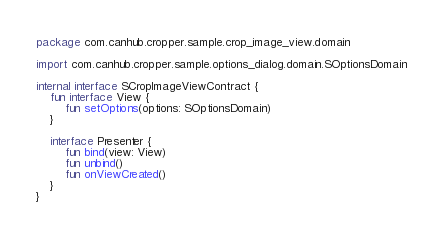Convert code to text. <code><loc_0><loc_0><loc_500><loc_500><_Kotlin_>package com.canhub.cropper.sample.crop_image_view.domain

import com.canhub.cropper.sample.options_dialog.domain.SOptionsDomain

internal interface SCropImageViewContract {
    fun interface View {
        fun setOptions(options: SOptionsDomain)
    }

    interface Presenter {
        fun bind(view: View)
        fun unbind()
        fun onViewCreated()
    }
}
</code> 